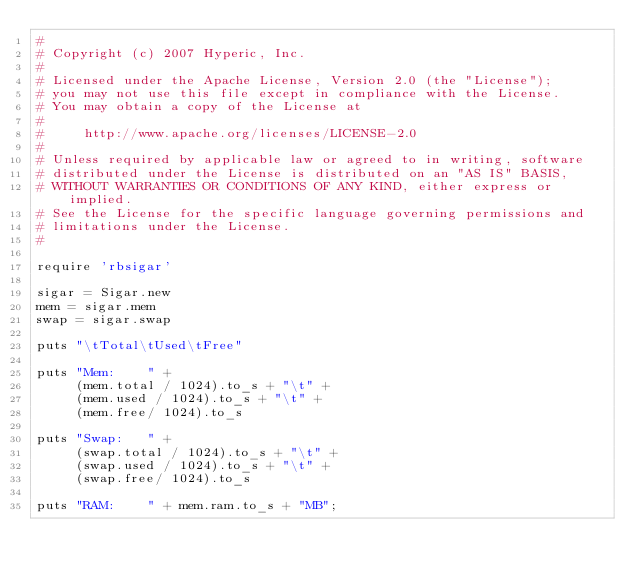Convert code to text. <code><loc_0><loc_0><loc_500><loc_500><_Ruby_>#
# Copyright (c) 2007 Hyperic, Inc.
#
# Licensed under the Apache License, Version 2.0 (the "License");
# you may not use this file except in compliance with the License.
# You may obtain a copy of the License at
#
#     http://www.apache.org/licenses/LICENSE-2.0
#
# Unless required by applicable law or agreed to in writing, software
# distributed under the License is distributed on an "AS IS" BASIS,
# WITHOUT WARRANTIES OR CONDITIONS OF ANY KIND, either express or implied.
# See the License for the specific language governing permissions and
# limitations under the License.
#

require 'rbsigar'

sigar = Sigar.new
mem = sigar.mem
swap = sigar.swap

puts "\tTotal\tUsed\tFree"

puts "Mem:    " +
     (mem.total / 1024).to_s + "\t" +
     (mem.used / 1024).to_s + "\t" +
     (mem.free/ 1024).to_s

puts "Swap:   " +
     (swap.total / 1024).to_s + "\t" +
     (swap.used / 1024).to_s + "\t" +
     (swap.free/ 1024).to_s

puts "RAM:    " + mem.ram.to_s + "MB";
</code> 